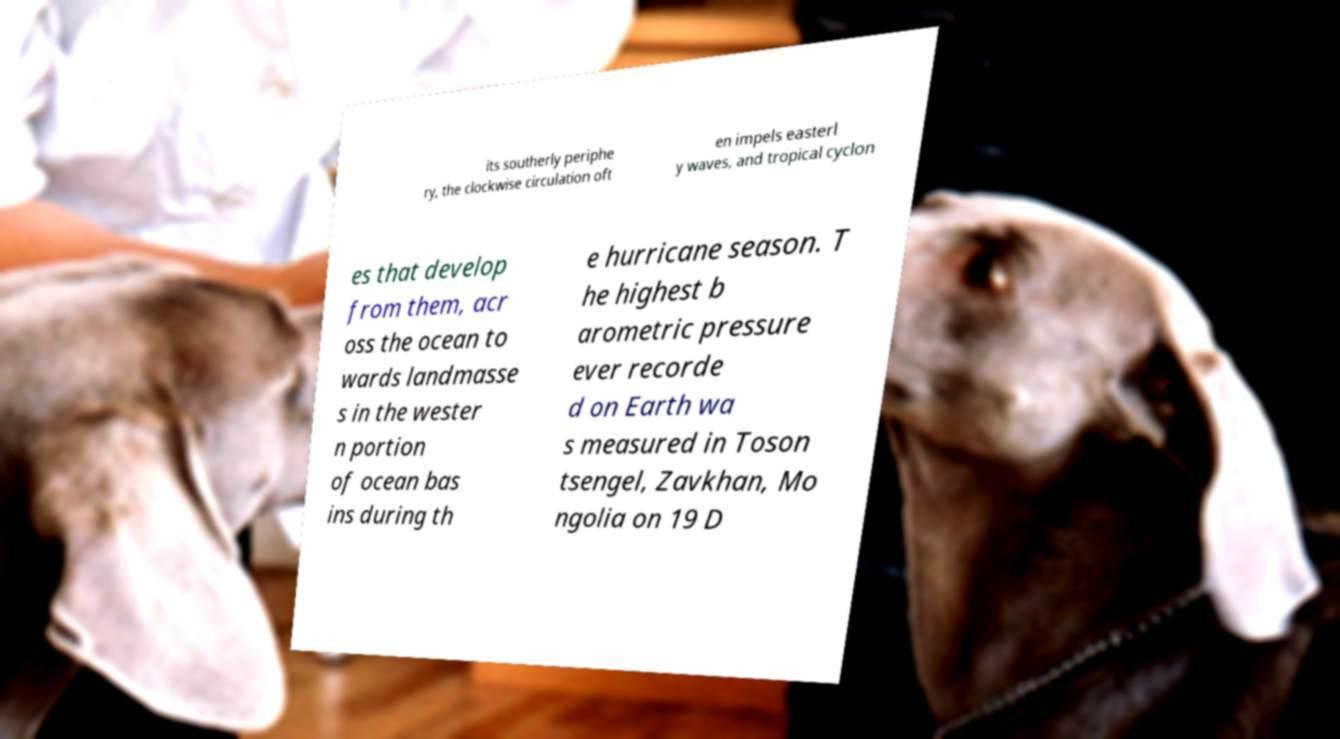Can you accurately transcribe the text from the provided image for me? its southerly periphe ry, the clockwise circulation oft en impels easterl y waves, and tropical cyclon es that develop from them, acr oss the ocean to wards landmasse s in the wester n portion of ocean bas ins during th e hurricane season. T he highest b arometric pressure ever recorde d on Earth wa s measured in Toson tsengel, Zavkhan, Mo ngolia on 19 D 